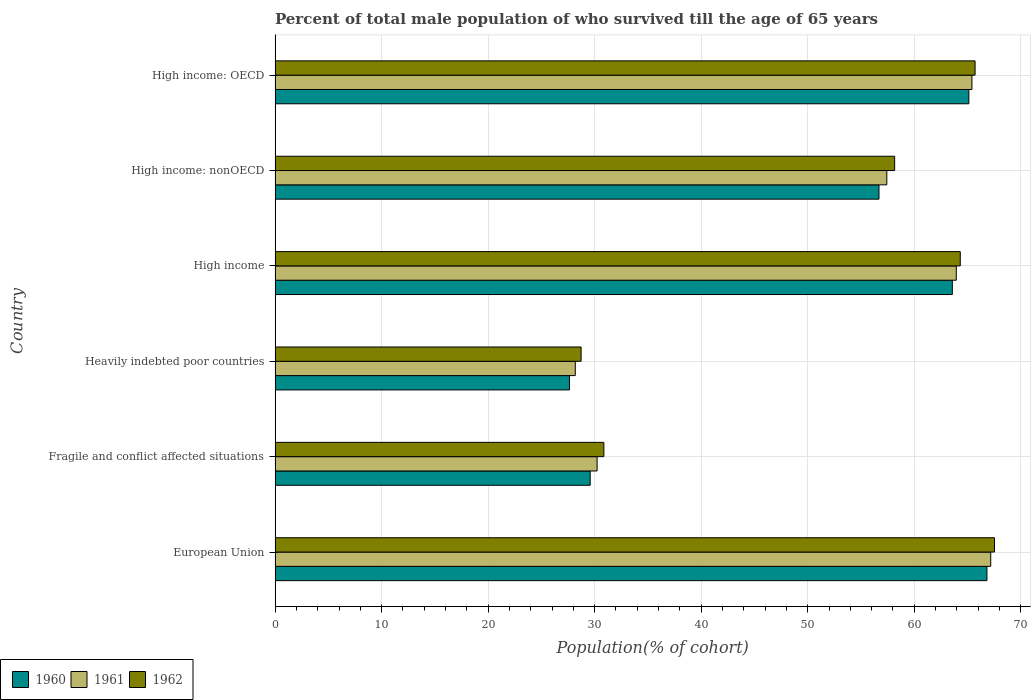Are the number of bars per tick equal to the number of legend labels?
Your answer should be compact. Yes. Are the number of bars on each tick of the Y-axis equal?
Your answer should be compact. Yes. In how many cases, is the number of bars for a given country not equal to the number of legend labels?
Offer a terse response. 0. What is the percentage of total male population who survived till the age of 65 years in 1960 in High income: OECD?
Your answer should be compact. 65.13. Across all countries, what is the maximum percentage of total male population who survived till the age of 65 years in 1960?
Give a very brief answer. 66.83. Across all countries, what is the minimum percentage of total male population who survived till the age of 65 years in 1962?
Offer a terse response. 28.73. In which country was the percentage of total male population who survived till the age of 65 years in 1962 minimum?
Offer a very short reply. Heavily indebted poor countries. What is the total percentage of total male population who survived till the age of 65 years in 1960 in the graph?
Make the answer very short. 309.44. What is the difference between the percentage of total male population who survived till the age of 65 years in 1960 in European Union and that in High income: OECD?
Keep it short and to the point. 1.7. What is the difference between the percentage of total male population who survived till the age of 65 years in 1961 in High income: OECD and the percentage of total male population who survived till the age of 65 years in 1962 in High income: nonOECD?
Make the answer very short. 7.25. What is the average percentage of total male population who survived till the age of 65 years in 1962 per country?
Provide a short and direct response. 52.55. What is the difference between the percentage of total male population who survived till the age of 65 years in 1961 and percentage of total male population who survived till the age of 65 years in 1960 in High income: OECD?
Your answer should be very brief. 0.29. In how many countries, is the percentage of total male population who survived till the age of 65 years in 1962 greater than 34 %?
Your answer should be very brief. 4. What is the ratio of the percentage of total male population who survived till the age of 65 years in 1960 in High income to that in High income: OECD?
Offer a very short reply. 0.98. Is the difference between the percentage of total male population who survived till the age of 65 years in 1961 in European Union and High income: OECD greater than the difference between the percentage of total male population who survived till the age of 65 years in 1960 in European Union and High income: OECD?
Give a very brief answer. Yes. What is the difference between the highest and the second highest percentage of total male population who survived till the age of 65 years in 1960?
Provide a succinct answer. 1.7. What is the difference between the highest and the lowest percentage of total male population who survived till the age of 65 years in 1961?
Offer a terse response. 39. What does the 2nd bar from the top in Heavily indebted poor countries represents?
Keep it short and to the point. 1961. Is it the case that in every country, the sum of the percentage of total male population who survived till the age of 65 years in 1962 and percentage of total male population who survived till the age of 65 years in 1960 is greater than the percentage of total male population who survived till the age of 65 years in 1961?
Provide a succinct answer. Yes. How many bars are there?
Give a very brief answer. 18. How many countries are there in the graph?
Offer a terse response. 6. What is the difference between two consecutive major ticks on the X-axis?
Ensure brevity in your answer.  10. Are the values on the major ticks of X-axis written in scientific E-notation?
Your response must be concise. No. Does the graph contain any zero values?
Your response must be concise. No. Where does the legend appear in the graph?
Give a very brief answer. Bottom left. How many legend labels are there?
Offer a terse response. 3. What is the title of the graph?
Your answer should be compact. Percent of total male population of who survived till the age of 65 years. What is the label or title of the X-axis?
Your answer should be very brief. Population(% of cohort). What is the Population(% of cohort) of 1960 in European Union?
Make the answer very short. 66.83. What is the Population(% of cohort) of 1961 in European Union?
Your answer should be compact. 67.18. What is the Population(% of cohort) of 1962 in European Union?
Offer a terse response. 67.54. What is the Population(% of cohort) of 1960 in Fragile and conflict affected situations?
Provide a succinct answer. 29.58. What is the Population(% of cohort) of 1961 in Fragile and conflict affected situations?
Your answer should be very brief. 30.23. What is the Population(% of cohort) of 1962 in Fragile and conflict affected situations?
Offer a terse response. 30.86. What is the Population(% of cohort) of 1960 in Heavily indebted poor countries?
Keep it short and to the point. 27.64. What is the Population(% of cohort) of 1961 in Heavily indebted poor countries?
Ensure brevity in your answer.  28.18. What is the Population(% of cohort) in 1962 in Heavily indebted poor countries?
Offer a very short reply. 28.73. What is the Population(% of cohort) in 1960 in High income?
Give a very brief answer. 63.58. What is the Population(% of cohort) of 1961 in High income?
Offer a terse response. 63.95. What is the Population(% of cohort) in 1962 in High income?
Provide a short and direct response. 64.32. What is the Population(% of cohort) in 1960 in High income: nonOECD?
Provide a succinct answer. 56.69. What is the Population(% of cohort) in 1961 in High income: nonOECD?
Provide a succinct answer. 57.43. What is the Population(% of cohort) in 1962 in High income: nonOECD?
Give a very brief answer. 58.16. What is the Population(% of cohort) of 1960 in High income: OECD?
Your answer should be very brief. 65.13. What is the Population(% of cohort) in 1961 in High income: OECD?
Give a very brief answer. 65.42. What is the Population(% of cohort) of 1962 in High income: OECD?
Your answer should be compact. 65.71. Across all countries, what is the maximum Population(% of cohort) in 1960?
Give a very brief answer. 66.83. Across all countries, what is the maximum Population(% of cohort) of 1961?
Give a very brief answer. 67.18. Across all countries, what is the maximum Population(% of cohort) in 1962?
Provide a short and direct response. 67.54. Across all countries, what is the minimum Population(% of cohort) in 1960?
Your answer should be compact. 27.64. Across all countries, what is the minimum Population(% of cohort) in 1961?
Provide a succinct answer. 28.18. Across all countries, what is the minimum Population(% of cohort) in 1962?
Your answer should be very brief. 28.73. What is the total Population(% of cohort) of 1960 in the graph?
Offer a terse response. 309.44. What is the total Population(% of cohort) in 1961 in the graph?
Offer a very short reply. 312.39. What is the total Population(% of cohort) in 1962 in the graph?
Provide a succinct answer. 315.33. What is the difference between the Population(% of cohort) in 1960 in European Union and that in Fragile and conflict affected situations?
Offer a very short reply. 37.24. What is the difference between the Population(% of cohort) in 1961 in European Union and that in Fragile and conflict affected situations?
Give a very brief answer. 36.95. What is the difference between the Population(% of cohort) of 1962 in European Union and that in Fragile and conflict affected situations?
Offer a terse response. 36.67. What is the difference between the Population(% of cohort) of 1960 in European Union and that in Heavily indebted poor countries?
Your answer should be very brief. 39.19. What is the difference between the Population(% of cohort) in 1961 in European Union and that in Heavily indebted poor countries?
Your response must be concise. 39. What is the difference between the Population(% of cohort) in 1962 in European Union and that in Heavily indebted poor countries?
Provide a succinct answer. 38.81. What is the difference between the Population(% of cohort) of 1960 in European Union and that in High income?
Your answer should be compact. 3.25. What is the difference between the Population(% of cohort) in 1961 in European Union and that in High income?
Make the answer very short. 3.23. What is the difference between the Population(% of cohort) in 1962 in European Union and that in High income?
Keep it short and to the point. 3.22. What is the difference between the Population(% of cohort) of 1960 in European Union and that in High income: nonOECD?
Make the answer very short. 10.13. What is the difference between the Population(% of cohort) of 1961 in European Union and that in High income: nonOECD?
Keep it short and to the point. 9.75. What is the difference between the Population(% of cohort) of 1962 in European Union and that in High income: nonOECD?
Provide a short and direct response. 9.38. What is the difference between the Population(% of cohort) of 1960 in European Union and that in High income: OECD?
Provide a succinct answer. 1.7. What is the difference between the Population(% of cohort) in 1961 in European Union and that in High income: OECD?
Your answer should be compact. 1.77. What is the difference between the Population(% of cohort) in 1962 in European Union and that in High income: OECD?
Your answer should be very brief. 1.82. What is the difference between the Population(% of cohort) in 1960 in Fragile and conflict affected situations and that in Heavily indebted poor countries?
Offer a very short reply. 1.95. What is the difference between the Population(% of cohort) in 1961 in Fragile and conflict affected situations and that in Heavily indebted poor countries?
Your answer should be compact. 2.05. What is the difference between the Population(% of cohort) in 1962 in Fragile and conflict affected situations and that in Heavily indebted poor countries?
Keep it short and to the point. 2.14. What is the difference between the Population(% of cohort) in 1960 in Fragile and conflict affected situations and that in High income?
Provide a short and direct response. -33.99. What is the difference between the Population(% of cohort) in 1961 in Fragile and conflict affected situations and that in High income?
Your answer should be very brief. -33.72. What is the difference between the Population(% of cohort) in 1962 in Fragile and conflict affected situations and that in High income?
Your answer should be compact. -33.46. What is the difference between the Population(% of cohort) in 1960 in Fragile and conflict affected situations and that in High income: nonOECD?
Offer a very short reply. -27.11. What is the difference between the Population(% of cohort) of 1961 in Fragile and conflict affected situations and that in High income: nonOECD?
Keep it short and to the point. -27.2. What is the difference between the Population(% of cohort) of 1962 in Fragile and conflict affected situations and that in High income: nonOECD?
Your answer should be compact. -27.3. What is the difference between the Population(% of cohort) in 1960 in Fragile and conflict affected situations and that in High income: OECD?
Your answer should be very brief. -35.55. What is the difference between the Population(% of cohort) in 1961 in Fragile and conflict affected situations and that in High income: OECD?
Provide a succinct answer. -35.19. What is the difference between the Population(% of cohort) of 1962 in Fragile and conflict affected situations and that in High income: OECD?
Provide a short and direct response. -34.85. What is the difference between the Population(% of cohort) of 1960 in Heavily indebted poor countries and that in High income?
Provide a short and direct response. -35.94. What is the difference between the Population(% of cohort) of 1961 in Heavily indebted poor countries and that in High income?
Make the answer very short. -35.77. What is the difference between the Population(% of cohort) in 1962 in Heavily indebted poor countries and that in High income?
Keep it short and to the point. -35.59. What is the difference between the Population(% of cohort) in 1960 in Heavily indebted poor countries and that in High income: nonOECD?
Provide a short and direct response. -29.06. What is the difference between the Population(% of cohort) in 1961 in Heavily indebted poor countries and that in High income: nonOECD?
Keep it short and to the point. -29.25. What is the difference between the Population(% of cohort) of 1962 in Heavily indebted poor countries and that in High income: nonOECD?
Make the answer very short. -29.43. What is the difference between the Population(% of cohort) of 1960 in Heavily indebted poor countries and that in High income: OECD?
Your answer should be very brief. -37.49. What is the difference between the Population(% of cohort) of 1961 in Heavily indebted poor countries and that in High income: OECD?
Ensure brevity in your answer.  -37.23. What is the difference between the Population(% of cohort) of 1962 in Heavily indebted poor countries and that in High income: OECD?
Provide a succinct answer. -36.99. What is the difference between the Population(% of cohort) of 1960 in High income and that in High income: nonOECD?
Offer a very short reply. 6.88. What is the difference between the Population(% of cohort) in 1961 in High income and that in High income: nonOECD?
Your answer should be compact. 6.52. What is the difference between the Population(% of cohort) in 1962 in High income and that in High income: nonOECD?
Offer a terse response. 6.16. What is the difference between the Population(% of cohort) in 1960 in High income and that in High income: OECD?
Offer a very short reply. -1.55. What is the difference between the Population(% of cohort) of 1961 in High income and that in High income: OECD?
Your answer should be compact. -1.47. What is the difference between the Population(% of cohort) of 1962 in High income and that in High income: OECD?
Make the answer very short. -1.39. What is the difference between the Population(% of cohort) in 1960 in High income: nonOECD and that in High income: OECD?
Provide a succinct answer. -8.44. What is the difference between the Population(% of cohort) of 1961 in High income: nonOECD and that in High income: OECD?
Ensure brevity in your answer.  -7.99. What is the difference between the Population(% of cohort) in 1962 in High income: nonOECD and that in High income: OECD?
Your answer should be compact. -7.55. What is the difference between the Population(% of cohort) of 1960 in European Union and the Population(% of cohort) of 1961 in Fragile and conflict affected situations?
Ensure brevity in your answer.  36.6. What is the difference between the Population(% of cohort) of 1960 in European Union and the Population(% of cohort) of 1962 in Fragile and conflict affected situations?
Keep it short and to the point. 35.96. What is the difference between the Population(% of cohort) in 1961 in European Union and the Population(% of cohort) in 1962 in Fragile and conflict affected situations?
Keep it short and to the point. 36.32. What is the difference between the Population(% of cohort) of 1960 in European Union and the Population(% of cohort) of 1961 in Heavily indebted poor countries?
Your answer should be compact. 38.64. What is the difference between the Population(% of cohort) in 1960 in European Union and the Population(% of cohort) in 1962 in Heavily indebted poor countries?
Give a very brief answer. 38.1. What is the difference between the Population(% of cohort) of 1961 in European Union and the Population(% of cohort) of 1962 in Heavily indebted poor countries?
Provide a short and direct response. 38.45. What is the difference between the Population(% of cohort) of 1960 in European Union and the Population(% of cohort) of 1961 in High income?
Provide a succinct answer. 2.88. What is the difference between the Population(% of cohort) in 1960 in European Union and the Population(% of cohort) in 1962 in High income?
Your answer should be very brief. 2.5. What is the difference between the Population(% of cohort) of 1961 in European Union and the Population(% of cohort) of 1962 in High income?
Offer a very short reply. 2.86. What is the difference between the Population(% of cohort) in 1960 in European Union and the Population(% of cohort) in 1961 in High income: nonOECD?
Keep it short and to the point. 9.4. What is the difference between the Population(% of cohort) of 1960 in European Union and the Population(% of cohort) of 1962 in High income: nonOECD?
Your response must be concise. 8.66. What is the difference between the Population(% of cohort) in 1961 in European Union and the Population(% of cohort) in 1962 in High income: nonOECD?
Your answer should be very brief. 9.02. What is the difference between the Population(% of cohort) of 1960 in European Union and the Population(% of cohort) of 1961 in High income: OECD?
Make the answer very short. 1.41. What is the difference between the Population(% of cohort) of 1960 in European Union and the Population(% of cohort) of 1962 in High income: OECD?
Give a very brief answer. 1.11. What is the difference between the Population(% of cohort) in 1961 in European Union and the Population(% of cohort) in 1962 in High income: OECD?
Provide a short and direct response. 1.47. What is the difference between the Population(% of cohort) in 1960 in Fragile and conflict affected situations and the Population(% of cohort) in 1962 in Heavily indebted poor countries?
Ensure brevity in your answer.  0.85. What is the difference between the Population(% of cohort) of 1961 in Fragile and conflict affected situations and the Population(% of cohort) of 1962 in Heavily indebted poor countries?
Keep it short and to the point. 1.5. What is the difference between the Population(% of cohort) in 1960 in Fragile and conflict affected situations and the Population(% of cohort) in 1961 in High income?
Your answer should be compact. -34.37. What is the difference between the Population(% of cohort) of 1960 in Fragile and conflict affected situations and the Population(% of cohort) of 1962 in High income?
Give a very brief answer. -34.74. What is the difference between the Population(% of cohort) in 1961 in Fragile and conflict affected situations and the Population(% of cohort) in 1962 in High income?
Ensure brevity in your answer.  -34.09. What is the difference between the Population(% of cohort) of 1960 in Fragile and conflict affected situations and the Population(% of cohort) of 1961 in High income: nonOECD?
Make the answer very short. -27.85. What is the difference between the Population(% of cohort) of 1960 in Fragile and conflict affected situations and the Population(% of cohort) of 1962 in High income: nonOECD?
Ensure brevity in your answer.  -28.58. What is the difference between the Population(% of cohort) of 1961 in Fragile and conflict affected situations and the Population(% of cohort) of 1962 in High income: nonOECD?
Offer a terse response. -27.93. What is the difference between the Population(% of cohort) of 1960 in Fragile and conflict affected situations and the Population(% of cohort) of 1961 in High income: OECD?
Your answer should be very brief. -35.83. What is the difference between the Population(% of cohort) of 1960 in Fragile and conflict affected situations and the Population(% of cohort) of 1962 in High income: OECD?
Provide a short and direct response. -36.13. What is the difference between the Population(% of cohort) in 1961 in Fragile and conflict affected situations and the Population(% of cohort) in 1962 in High income: OECD?
Your answer should be very brief. -35.48. What is the difference between the Population(% of cohort) in 1960 in Heavily indebted poor countries and the Population(% of cohort) in 1961 in High income?
Ensure brevity in your answer.  -36.31. What is the difference between the Population(% of cohort) of 1960 in Heavily indebted poor countries and the Population(% of cohort) of 1962 in High income?
Your response must be concise. -36.69. What is the difference between the Population(% of cohort) in 1961 in Heavily indebted poor countries and the Population(% of cohort) in 1962 in High income?
Provide a succinct answer. -36.14. What is the difference between the Population(% of cohort) of 1960 in Heavily indebted poor countries and the Population(% of cohort) of 1961 in High income: nonOECD?
Provide a succinct answer. -29.79. What is the difference between the Population(% of cohort) of 1960 in Heavily indebted poor countries and the Population(% of cohort) of 1962 in High income: nonOECD?
Offer a very short reply. -30.53. What is the difference between the Population(% of cohort) in 1961 in Heavily indebted poor countries and the Population(% of cohort) in 1962 in High income: nonOECD?
Your answer should be very brief. -29.98. What is the difference between the Population(% of cohort) in 1960 in Heavily indebted poor countries and the Population(% of cohort) in 1961 in High income: OECD?
Ensure brevity in your answer.  -37.78. What is the difference between the Population(% of cohort) of 1960 in Heavily indebted poor countries and the Population(% of cohort) of 1962 in High income: OECD?
Your answer should be compact. -38.08. What is the difference between the Population(% of cohort) in 1961 in Heavily indebted poor countries and the Population(% of cohort) in 1962 in High income: OECD?
Make the answer very short. -37.53. What is the difference between the Population(% of cohort) in 1960 in High income and the Population(% of cohort) in 1961 in High income: nonOECD?
Your answer should be very brief. 6.15. What is the difference between the Population(% of cohort) in 1960 in High income and the Population(% of cohort) in 1962 in High income: nonOECD?
Your response must be concise. 5.41. What is the difference between the Population(% of cohort) in 1961 in High income and the Population(% of cohort) in 1962 in High income: nonOECD?
Your response must be concise. 5.79. What is the difference between the Population(% of cohort) of 1960 in High income and the Population(% of cohort) of 1961 in High income: OECD?
Your response must be concise. -1.84. What is the difference between the Population(% of cohort) of 1960 in High income and the Population(% of cohort) of 1962 in High income: OECD?
Your answer should be compact. -2.14. What is the difference between the Population(% of cohort) of 1961 in High income and the Population(% of cohort) of 1962 in High income: OECD?
Keep it short and to the point. -1.76. What is the difference between the Population(% of cohort) of 1960 in High income: nonOECD and the Population(% of cohort) of 1961 in High income: OECD?
Ensure brevity in your answer.  -8.72. What is the difference between the Population(% of cohort) of 1960 in High income: nonOECD and the Population(% of cohort) of 1962 in High income: OECD?
Provide a short and direct response. -9.02. What is the difference between the Population(% of cohort) of 1961 in High income: nonOECD and the Population(% of cohort) of 1962 in High income: OECD?
Your answer should be compact. -8.29. What is the average Population(% of cohort) in 1960 per country?
Provide a short and direct response. 51.57. What is the average Population(% of cohort) in 1961 per country?
Provide a short and direct response. 52.06. What is the average Population(% of cohort) in 1962 per country?
Give a very brief answer. 52.55. What is the difference between the Population(% of cohort) of 1960 and Population(% of cohort) of 1961 in European Union?
Your response must be concise. -0.36. What is the difference between the Population(% of cohort) of 1960 and Population(% of cohort) of 1962 in European Union?
Provide a short and direct response. -0.71. What is the difference between the Population(% of cohort) in 1961 and Population(% of cohort) in 1962 in European Union?
Ensure brevity in your answer.  -0.36. What is the difference between the Population(% of cohort) of 1960 and Population(% of cohort) of 1961 in Fragile and conflict affected situations?
Make the answer very short. -0.65. What is the difference between the Population(% of cohort) of 1960 and Population(% of cohort) of 1962 in Fragile and conflict affected situations?
Your answer should be very brief. -1.28. What is the difference between the Population(% of cohort) in 1961 and Population(% of cohort) in 1962 in Fragile and conflict affected situations?
Provide a succinct answer. -0.63. What is the difference between the Population(% of cohort) of 1960 and Population(% of cohort) of 1961 in Heavily indebted poor countries?
Provide a short and direct response. -0.55. What is the difference between the Population(% of cohort) of 1960 and Population(% of cohort) of 1962 in Heavily indebted poor countries?
Keep it short and to the point. -1.09. What is the difference between the Population(% of cohort) of 1961 and Population(% of cohort) of 1962 in Heavily indebted poor countries?
Your answer should be very brief. -0.55. What is the difference between the Population(% of cohort) in 1960 and Population(% of cohort) in 1961 in High income?
Offer a very short reply. -0.37. What is the difference between the Population(% of cohort) of 1960 and Population(% of cohort) of 1962 in High income?
Provide a succinct answer. -0.75. What is the difference between the Population(% of cohort) of 1961 and Population(% of cohort) of 1962 in High income?
Make the answer very short. -0.37. What is the difference between the Population(% of cohort) of 1960 and Population(% of cohort) of 1961 in High income: nonOECD?
Your answer should be compact. -0.74. What is the difference between the Population(% of cohort) of 1960 and Population(% of cohort) of 1962 in High income: nonOECD?
Offer a very short reply. -1.47. What is the difference between the Population(% of cohort) in 1961 and Population(% of cohort) in 1962 in High income: nonOECD?
Your answer should be very brief. -0.74. What is the difference between the Population(% of cohort) in 1960 and Population(% of cohort) in 1961 in High income: OECD?
Your response must be concise. -0.29. What is the difference between the Population(% of cohort) in 1960 and Population(% of cohort) in 1962 in High income: OECD?
Offer a terse response. -0.58. What is the difference between the Population(% of cohort) in 1961 and Population(% of cohort) in 1962 in High income: OECD?
Provide a succinct answer. -0.3. What is the ratio of the Population(% of cohort) in 1960 in European Union to that in Fragile and conflict affected situations?
Make the answer very short. 2.26. What is the ratio of the Population(% of cohort) of 1961 in European Union to that in Fragile and conflict affected situations?
Your response must be concise. 2.22. What is the ratio of the Population(% of cohort) in 1962 in European Union to that in Fragile and conflict affected situations?
Provide a succinct answer. 2.19. What is the ratio of the Population(% of cohort) in 1960 in European Union to that in Heavily indebted poor countries?
Give a very brief answer. 2.42. What is the ratio of the Population(% of cohort) in 1961 in European Union to that in Heavily indebted poor countries?
Your answer should be compact. 2.38. What is the ratio of the Population(% of cohort) in 1962 in European Union to that in Heavily indebted poor countries?
Provide a succinct answer. 2.35. What is the ratio of the Population(% of cohort) in 1960 in European Union to that in High income?
Provide a succinct answer. 1.05. What is the ratio of the Population(% of cohort) of 1961 in European Union to that in High income?
Give a very brief answer. 1.05. What is the ratio of the Population(% of cohort) in 1960 in European Union to that in High income: nonOECD?
Offer a very short reply. 1.18. What is the ratio of the Population(% of cohort) in 1961 in European Union to that in High income: nonOECD?
Your answer should be compact. 1.17. What is the ratio of the Population(% of cohort) of 1962 in European Union to that in High income: nonOECD?
Provide a succinct answer. 1.16. What is the ratio of the Population(% of cohort) of 1960 in European Union to that in High income: OECD?
Provide a short and direct response. 1.03. What is the ratio of the Population(% of cohort) of 1961 in European Union to that in High income: OECD?
Offer a terse response. 1.03. What is the ratio of the Population(% of cohort) of 1962 in European Union to that in High income: OECD?
Make the answer very short. 1.03. What is the ratio of the Population(% of cohort) in 1960 in Fragile and conflict affected situations to that in Heavily indebted poor countries?
Keep it short and to the point. 1.07. What is the ratio of the Population(% of cohort) in 1961 in Fragile and conflict affected situations to that in Heavily indebted poor countries?
Offer a terse response. 1.07. What is the ratio of the Population(% of cohort) of 1962 in Fragile and conflict affected situations to that in Heavily indebted poor countries?
Make the answer very short. 1.07. What is the ratio of the Population(% of cohort) of 1960 in Fragile and conflict affected situations to that in High income?
Provide a succinct answer. 0.47. What is the ratio of the Population(% of cohort) in 1961 in Fragile and conflict affected situations to that in High income?
Your answer should be compact. 0.47. What is the ratio of the Population(% of cohort) in 1962 in Fragile and conflict affected situations to that in High income?
Give a very brief answer. 0.48. What is the ratio of the Population(% of cohort) in 1960 in Fragile and conflict affected situations to that in High income: nonOECD?
Your answer should be compact. 0.52. What is the ratio of the Population(% of cohort) in 1961 in Fragile and conflict affected situations to that in High income: nonOECD?
Give a very brief answer. 0.53. What is the ratio of the Population(% of cohort) in 1962 in Fragile and conflict affected situations to that in High income: nonOECD?
Make the answer very short. 0.53. What is the ratio of the Population(% of cohort) of 1960 in Fragile and conflict affected situations to that in High income: OECD?
Provide a short and direct response. 0.45. What is the ratio of the Population(% of cohort) of 1961 in Fragile and conflict affected situations to that in High income: OECD?
Provide a short and direct response. 0.46. What is the ratio of the Population(% of cohort) in 1962 in Fragile and conflict affected situations to that in High income: OECD?
Make the answer very short. 0.47. What is the ratio of the Population(% of cohort) in 1960 in Heavily indebted poor countries to that in High income?
Make the answer very short. 0.43. What is the ratio of the Population(% of cohort) in 1961 in Heavily indebted poor countries to that in High income?
Provide a short and direct response. 0.44. What is the ratio of the Population(% of cohort) in 1962 in Heavily indebted poor countries to that in High income?
Provide a short and direct response. 0.45. What is the ratio of the Population(% of cohort) in 1960 in Heavily indebted poor countries to that in High income: nonOECD?
Offer a terse response. 0.49. What is the ratio of the Population(% of cohort) of 1961 in Heavily indebted poor countries to that in High income: nonOECD?
Your answer should be compact. 0.49. What is the ratio of the Population(% of cohort) in 1962 in Heavily indebted poor countries to that in High income: nonOECD?
Offer a very short reply. 0.49. What is the ratio of the Population(% of cohort) of 1960 in Heavily indebted poor countries to that in High income: OECD?
Your response must be concise. 0.42. What is the ratio of the Population(% of cohort) in 1961 in Heavily indebted poor countries to that in High income: OECD?
Offer a terse response. 0.43. What is the ratio of the Population(% of cohort) in 1962 in Heavily indebted poor countries to that in High income: OECD?
Keep it short and to the point. 0.44. What is the ratio of the Population(% of cohort) of 1960 in High income to that in High income: nonOECD?
Provide a short and direct response. 1.12. What is the ratio of the Population(% of cohort) of 1961 in High income to that in High income: nonOECD?
Your response must be concise. 1.11. What is the ratio of the Population(% of cohort) in 1962 in High income to that in High income: nonOECD?
Ensure brevity in your answer.  1.11. What is the ratio of the Population(% of cohort) of 1960 in High income to that in High income: OECD?
Make the answer very short. 0.98. What is the ratio of the Population(% of cohort) in 1961 in High income to that in High income: OECD?
Your answer should be very brief. 0.98. What is the ratio of the Population(% of cohort) of 1962 in High income to that in High income: OECD?
Ensure brevity in your answer.  0.98. What is the ratio of the Population(% of cohort) of 1960 in High income: nonOECD to that in High income: OECD?
Offer a very short reply. 0.87. What is the ratio of the Population(% of cohort) of 1961 in High income: nonOECD to that in High income: OECD?
Make the answer very short. 0.88. What is the ratio of the Population(% of cohort) of 1962 in High income: nonOECD to that in High income: OECD?
Your answer should be compact. 0.89. What is the difference between the highest and the second highest Population(% of cohort) in 1960?
Your answer should be very brief. 1.7. What is the difference between the highest and the second highest Population(% of cohort) in 1961?
Your answer should be very brief. 1.77. What is the difference between the highest and the second highest Population(% of cohort) in 1962?
Offer a terse response. 1.82. What is the difference between the highest and the lowest Population(% of cohort) of 1960?
Your answer should be compact. 39.19. What is the difference between the highest and the lowest Population(% of cohort) in 1961?
Offer a terse response. 39. What is the difference between the highest and the lowest Population(% of cohort) of 1962?
Provide a short and direct response. 38.81. 